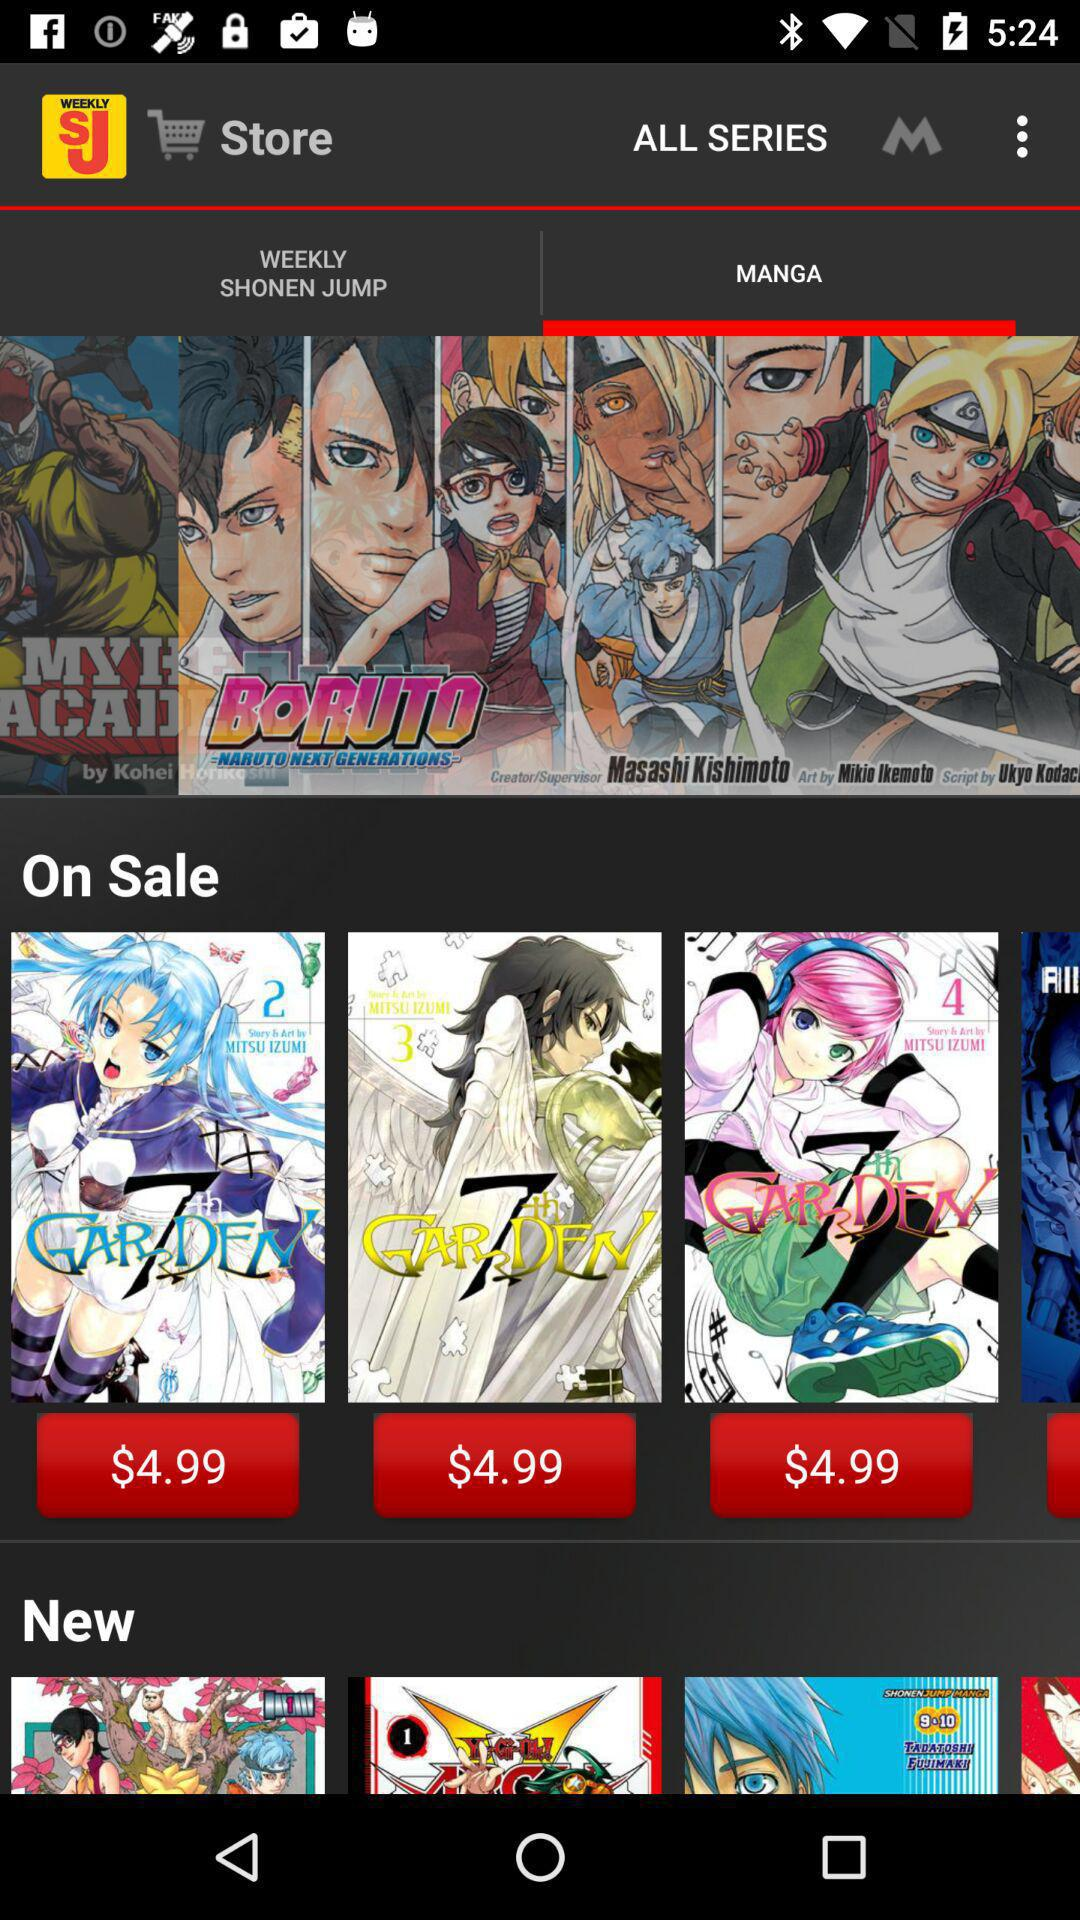What is the name of the series? The name of the series is Weekly Shonen Jump. 